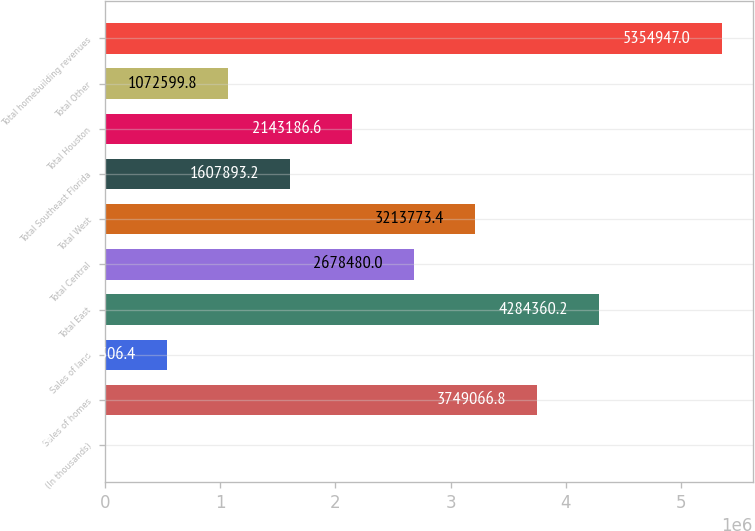Convert chart to OTSL. <chart><loc_0><loc_0><loc_500><loc_500><bar_chart><fcel>(In thousands)<fcel>Sales of homes<fcel>Sales of land<fcel>Total East<fcel>Total Central<fcel>Total West<fcel>Total Southeast Florida<fcel>Total Houston<fcel>Total Other<fcel>Total homebuilding revenues<nl><fcel>2013<fcel>3.74907e+06<fcel>537306<fcel>4.28436e+06<fcel>2.67848e+06<fcel>3.21377e+06<fcel>1.60789e+06<fcel>2.14319e+06<fcel>1.0726e+06<fcel>5.35495e+06<nl></chart> 